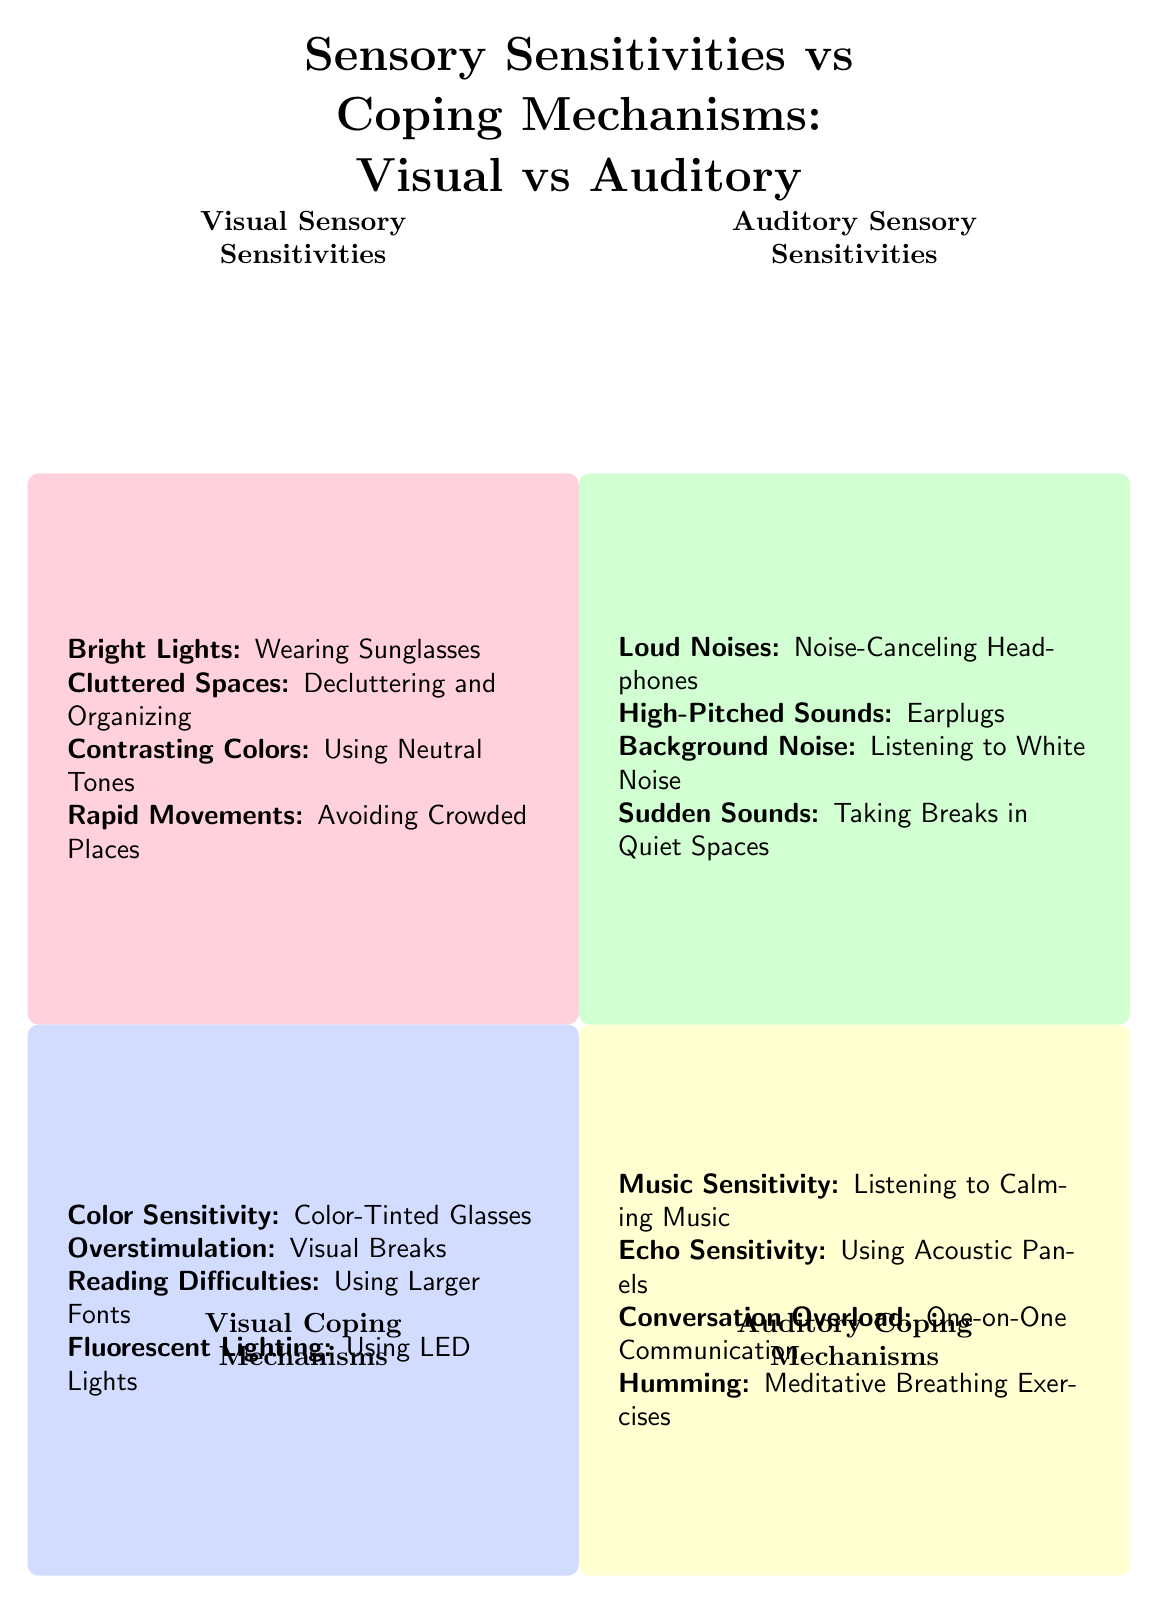What are the coping mechanisms for visual sensory sensitivities? The diagram indicates that the coping mechanisms for visual sensory sensitivities include Color-Tinted Glasses, Visual Breaks, Using Larger Fonts, and Using LED Lights. This information is found in the Visual Coping Mechanisms quadrant.
Answer: Color-Tinted Glasses, Visual Breaks, Using Larger Fonts, Using LED Lights How many auditory sensory sensitivities are listed? By counting the entries in the Auditory Sensory Sensitivities quadrant, we find that there are four specific sensitivities mentioned: Loud Noises, High-Pitched Sounds, Background Noise, and Sudden Sounds.
Answer: 4 What coping mechanism is suggested for loud noises? The diagram indicates that the suggested coping mechanism for loud noises is using Noise-Canceling Headphones, which is listed in the Auditory Coping Mechanisms quadrant.
Answer: Noise-Canceling Headphones If someone is sensitive to bright lights, what coping mechanism is recommended? According to the Visual Sensory Sensitivities quadrant, if someone is sensitive to bright lights, the coping mechanism recommended is Wearing Sunglasses. This direct response is found under the Visual Sensory Sensitivities section.
Answer: Wearing Sunglasses What coping mechanism might help with echo sensitivity? Under the Auditory Coping Mechanisms quadrant, the diagram lists using Acoustic Panels as a coping mechanism for echo sensitivity, specifically related to the auditory realm.
Answer: Using Acoustic Panels Which visual sensory sensitivity involves avoiding crowded places? The diagram specifies that the visual sensory sensitivity that involves avoiding crowded places is Rapid Movements, which is noted within the Visual Sensory Sensitivities quadrant.
Answer: Rapid Movements How many coping mechanisms are associated with auditory sensory sensitivities? By observing the Auditory Coping Mechanisms quadrant, we can identify four coping mechanisms associated with auditory sensitivities: Listening to Calming Music, Using Acoustic Panels, One-on-One Communication, and Meditative Breathing Exercises.
Answer: 4 Which coping mechanism is listed for background noise? The diagram notes that Listening to White Noise is the coping mechanism recommended for dealing with background noise, as outlined in the Auditory Sensory Sensitivities quadrant.
Answer: Listening to White Noise 